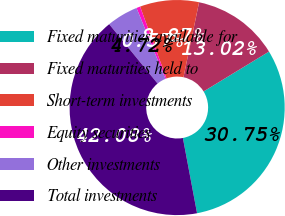Convert chart. <chart><loc_0><loc_0><loc_500><loc_500><pie_chart><fcel>Fixed maturities available for<fcel>Fixed maturities held to<fcel>Short-term investments<fcel>Equity securities<fcel>Other investments<fcel>Total investments<nl><fcel>30.75%<fcel>13.02%<fcel>8.87%<fcel>0.57%<fcel>4.72%<fcel>42.08%<nl></chart> 